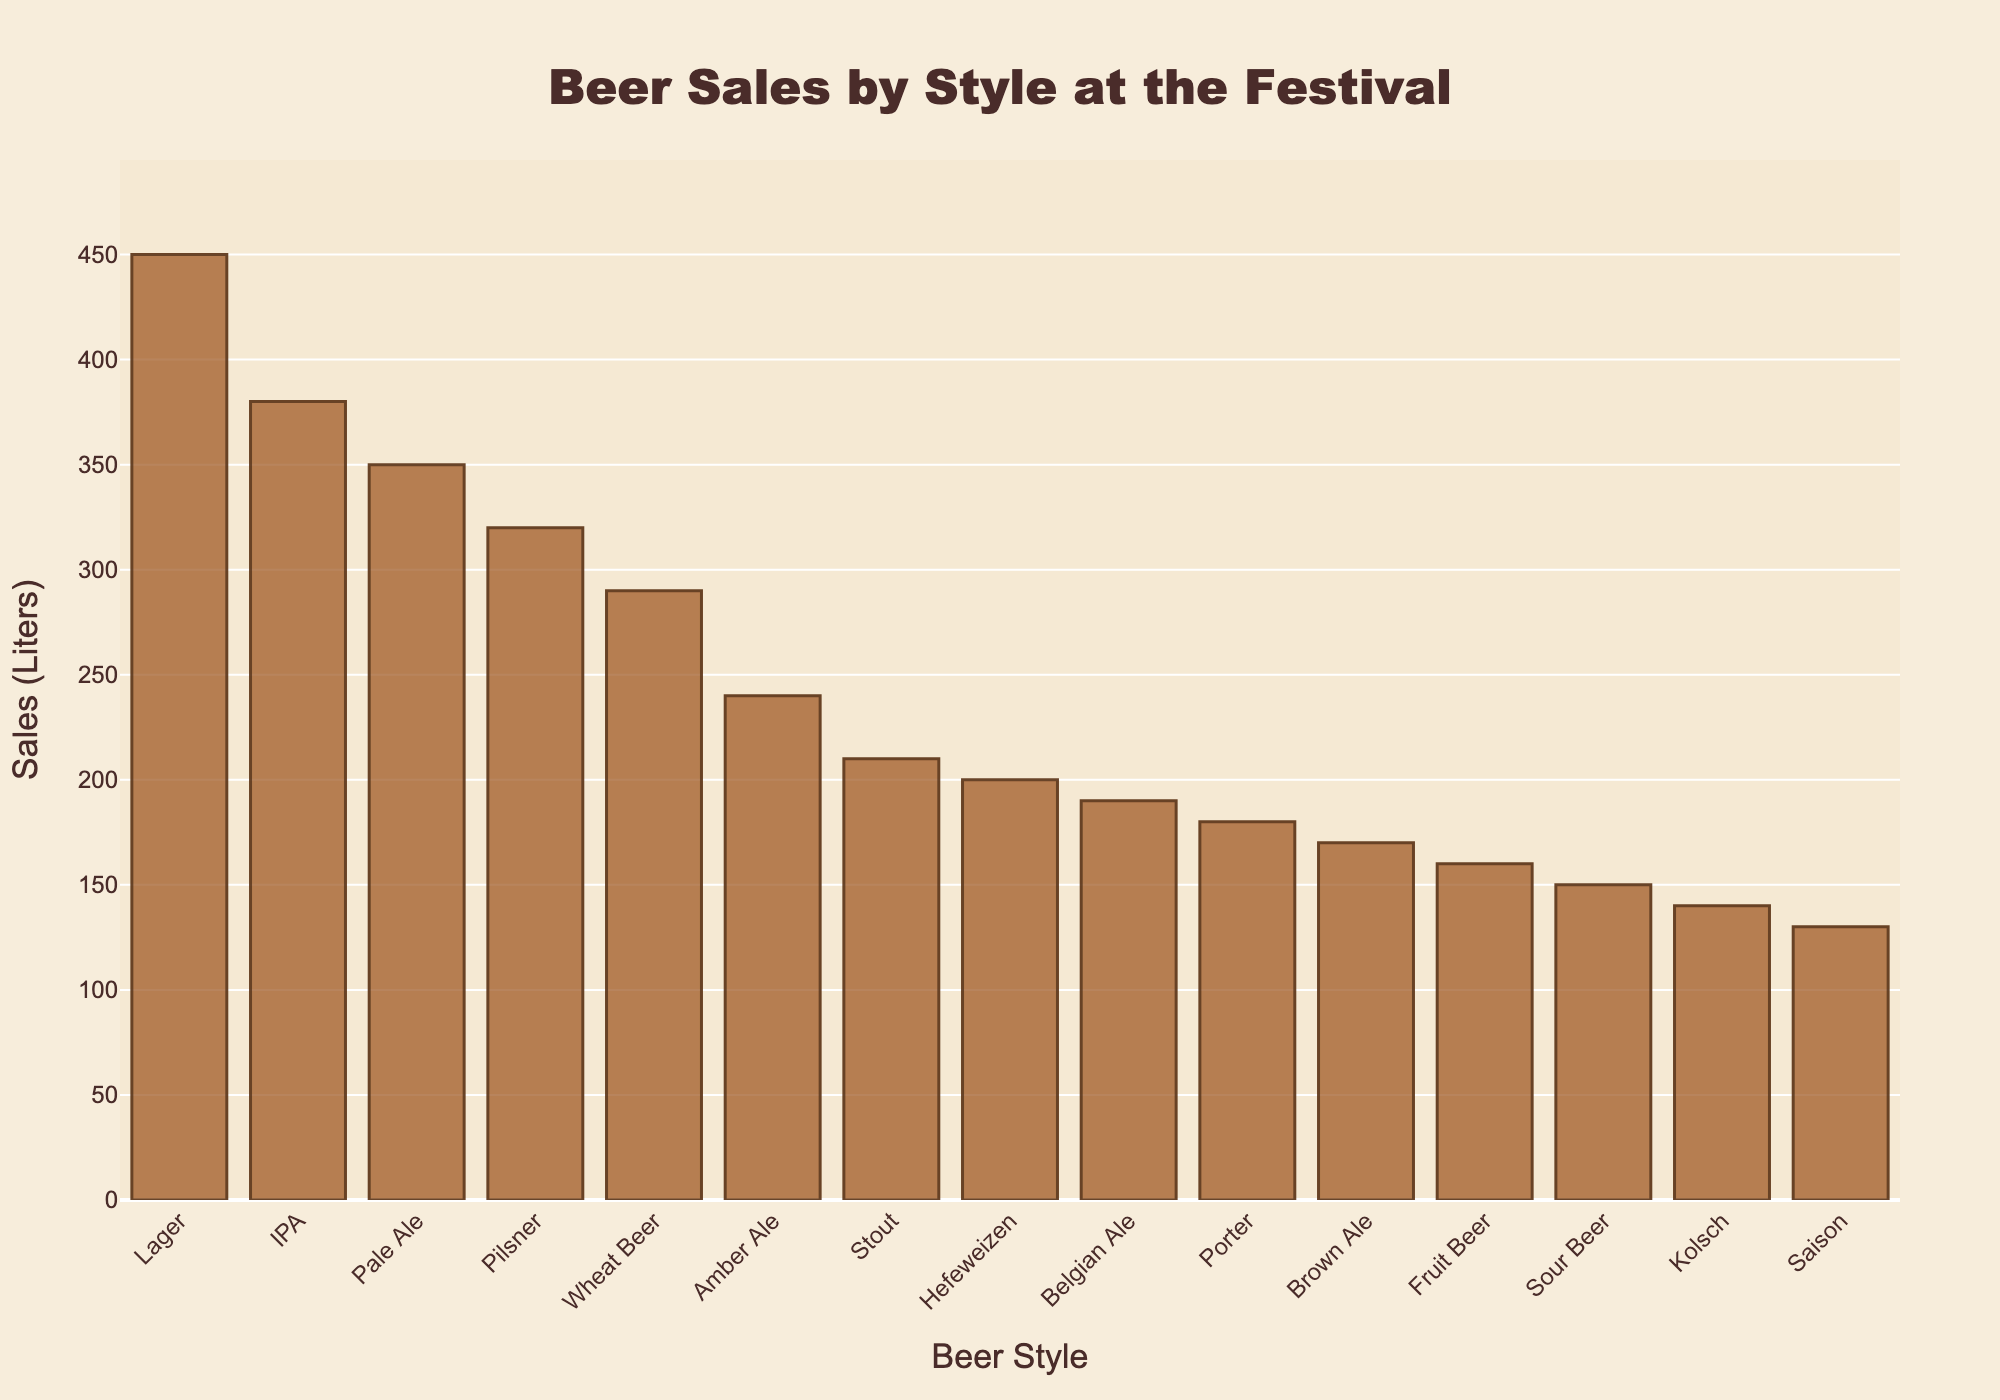What's the total sales of Lager and IPA combined? First, we find the sales of Lager, which is 450 liters. Then, we find the sales of IPA, which is 380 liters. We add these two values together: 450 + 380 = 830 liters.
Answer: 830 liters Which beer style has the lowest sales? We look for the shortest bar in the chart, which represents the lowest sales. This is the Saison, with 130 liters.
Answer: Saison How much more Lager was sold compared to Stout? First, we find the sales of Lager, which is 450 liters. Then, we find the sales of Stout, which is 210 liters. Subtract the sales of Stout from Lager: 450 - 210 = 240 liters.
Answer: 240 liters Rank the top three beer styles by sales. To determine the top three beer styles, we find the three tallest bars in descending order. The first is Lager (450 liters), the second is IPA (380 liters), and the third is Pale Ale (350 liters).
Answer: Lager, IPA, Pale Ale What is the average sales of the top three selling beer styles? First, we identify the top three beer styles: Lager (450 liters), IPA (380 liters), and Pale Ale (350 liters). We sum their sales: 450 + 380 + 350 = 1180 liters. Then, we divide by 3 to find the average: 1180 / 3 ≈ 393.33 liters.
Answer: 393.33 liters By how much does the sales of Wheat Beer exceed that of Belgian Ale? We first find the sales of Wheat Beer, which is 290 liters. Next, we see the sales of Belgian Ale, which is 190 liters. We subtract 190 from 290: 290 - 190 = 100 liters.
Answer: 100 liters Which beer styles have sales greater than 300 liters? We identify bars taller than the 300-liter mark. The beer styles are Lager (450 liters), IPA (380 liters), and Pale Ale (350 liters).
Answer: Lager, IPA, Pale Ale What is the difference in sales between the highest-selling and the lowest-selling beer styles? The highest-selling beer style is Lager (450 liters), and the lowest-selling is Saison (130 liters). Subtract 130 from 450: 450 - 130 = 320 liters.
Answer: 320 liters Which beer style ranks fifth in terms of sales? First, we sort the beer styles by sales in descending order. The fifth highest sales belong to Pilsner with 320 liters.
Answer: Pilsner How do the combined sales of Porter and Brown Ale compare to those of Lager? First, we find the sales of Porter (180 liters) and Brown Ale (170 liters). Combine their sales: 180 + 170 = 350 liters. Then, compare this to the sales of Lager, which is 450 liters. Since 350 < 450, Lager has higher sales.
Answer: Lager has higher sales 